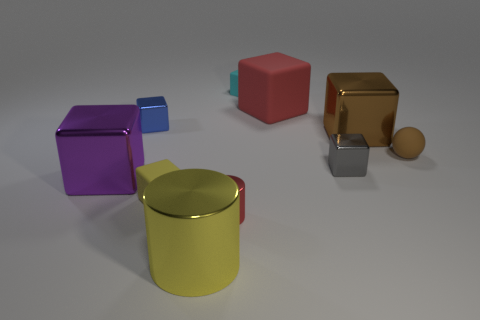Subtract all purple blocks. How many blocks are left? 6 Subtract all large red rubber blocks. How many blocks are left? 6 Subtract all green cubes. Subtract all gray balls. How many cubes are left? 7 Subtract all blocks. How many objects are left? 3 Add 4 small cyan blocks. How many small cyan blocks exist? 5 Subtract 0 yellow balls. How many objects are left? 10 Subtract all red cylinders. Subtract all large red matte cylinders. How many objects are left? 9 Add 2 red matte cubes. How many red matte cubes are left? 3 